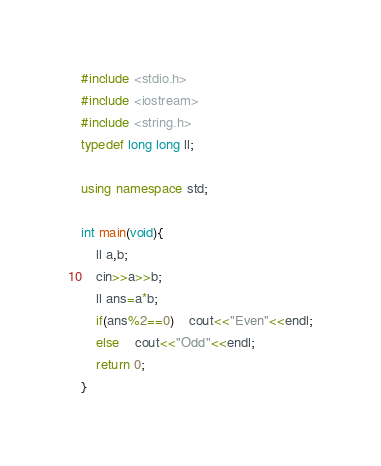<code> <loc_0><loc_0><loc_500><loc_500><_C++_>#include <stdio.h>
#include <iostream>
#include <string.h>
typedef long long ll;

using namespace std;

int main(void){
    ll a,b;
    cin>>a>>b;
    ll ans=a*b;
    if(ans%2==0)    cout<<"Even"<<endl;
    else    cout<<"Odd"<<endl;
    return 0;
}
</code> 